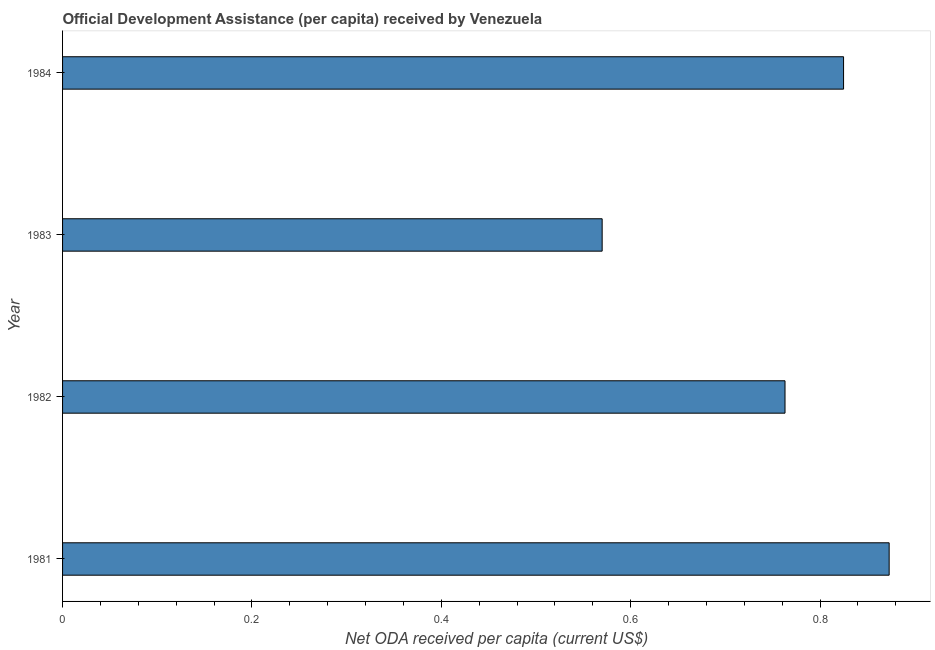Does the graph contain any zero values?
Your answer should be very brief. No. Does the graph contain grids?
Make the answer very short. No. What is the title of the graph?
Your answer should be very brief. Official Development Assistance (per capita) received by Venezuela. What is the label or title of the X-axis?
Ensure brevity in your answer.  Net ODA received per capita (current US$). What is the label or title of the Y-axis?
Your answer should be compact. Year. What is the net oda received per capita in 1984?
Make the answer very short. 0.82. Across all years, what is the maximum net oda received per capita?
Make the answer very short. 0.87. Across all years, what is the minimum net oda received per capita?
Your answer should be compact. 0.57. In which year was the net oda received per capita maximum?
Give a very brief answer. 1981. In which year was the net oda received per capita minimum?
Offer a very short reply. 1983. What is the sum of the net oda received per capita?
Your response must be concise. 3.03. What is the difference between the net oda received per capita in 1982 and 1984?
Make the answer very short. -0.06. What is the average net oda received per capita per year?
Your answer should be compact. 0.76. What is the median net oda received per capita?
Keep it short and to the point. 0.79. What is the ratio of the net oda received per capita in 1982 to that in 1983?
Provide a short and direct response. 1.34. What is the difference between the highest and the second highest net oda received per capita?
Ensure brevity in your answer.  0.05. Is the sum of the net oda received per capita in 1982 and 1984 greater than the maximum net oda received per capita across all years?
Offer a terse response. Yes. In how many years, is the net oda received per capita greater than the average net oda received per capita taken over all years?
Offer a very short reply. 3. How many bars are there?
Make the answer very short. 4. What is the difference between two consecutive major ticks on the X-axis?
Offer a terse response. 0.2. Are the values on the major ticks of X-axis written in scientific E-notation?
Provide a short and direct response. No. What is the Net ODA received per capita (current US$) in 1981?
Offer a terse response. 0.87. What is the Net ODA received per capita (current US$) in 1982?
Your answer should be very brief. 0.76. What is the Net ODA received per capita (current US$) of 1983?
Your response must be concise. 0.57. What is the Net ODA received per capita (current US$) of 1984?
Keep it short and to the point. 0.82. What is the difference between the Net ODA received per capita (current US$) in 1981 and 1982?
Provide a short and direct response. 0.11. What is the difference between the Net ODA received per capita (current US$) in 1981 and 1983?
Provide a short and direct response. 0.3. What is the difference between the Net ODA received per capita (current US$) in 1981 and 1984?
Your answer should be very brief. 0.05. What is the difference between the Net ODA received per capita (current US$) in 1982 and 1983?
Provide a succinct answer. 0.19. What is the difference between the Net ODA received per capita (current US$) in 1982 and 1984?
Your response must be concise. -0.06. What is the difference between the Net ODA received per capita (current US$) in 1983 and 1984?
Provide a succinct answer. -0.25. What is the ratio of the Net ODA received per capita (current US$) in 1981 to that in 1982?
Offer a very short reply. 1.14. What is the ratio of the Net ODA received per capita (current US$) in 1981 to that in 1983?
Give a very brief answer. 1.53. What is the ratio of the Net ODA received per capita (current US$) in 1981 to that in 1984?
Make the answer very short. 1.06. What is the ratio of the Net ODA received per capita (current US$) in 1982 to that in 1983?
Your answer should be very brief. 1.34. What is the ratio of the Net ODA received per capita (current US$) in 1982 to that in 1984?
Your response must be concise. 0.93. What is the ratio of the Net ODA received per capita (current US$) in 1983 to that in 1984?
Your answer should be compact. 0.69. 